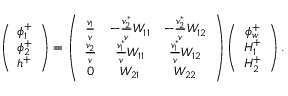Convert formula to latex. <formula><loc_0><loc_0><loc_500><loc_500>\left ( \begin{array} { c } { { \phi _ { 1 } ^ { + } } } \\ { { \phi _ { 2 } ^ { + } } } \\ { { h ^ { + } } } \end{array} \right ) = \left ( \begin{array} { c c c } { { \frac { v _ { 1 } } { v } } } & { { - \frac { v _ { 2 } ^ { * } } { v } W _ { 1 1 } } } & { { - \frac { v _ { 2 } ^ { * } } { v } W _ { 1 2 } } } \\ { { \frac { v _ { 2 } } { v } } } & { { \frac { v _ { 1 } ^ { * } } { v } W _ { 1 1 } } } & { { \frac { v _ { 1 } ^ { * } } { v } W _ { 1 2 } } } \\ { 0 } & { { W _ { 2 1 } } } & { { W _ { 2 2 } } } \end{array} \right ) \left ( \begin{array} { c } { { \phi _ { w } ^ { + } } } \\ { { H _ { 1 } ^ { + } } } \\ { { H _ { 2 } ^ { + } } } \end{array} \right ) .</formula> 